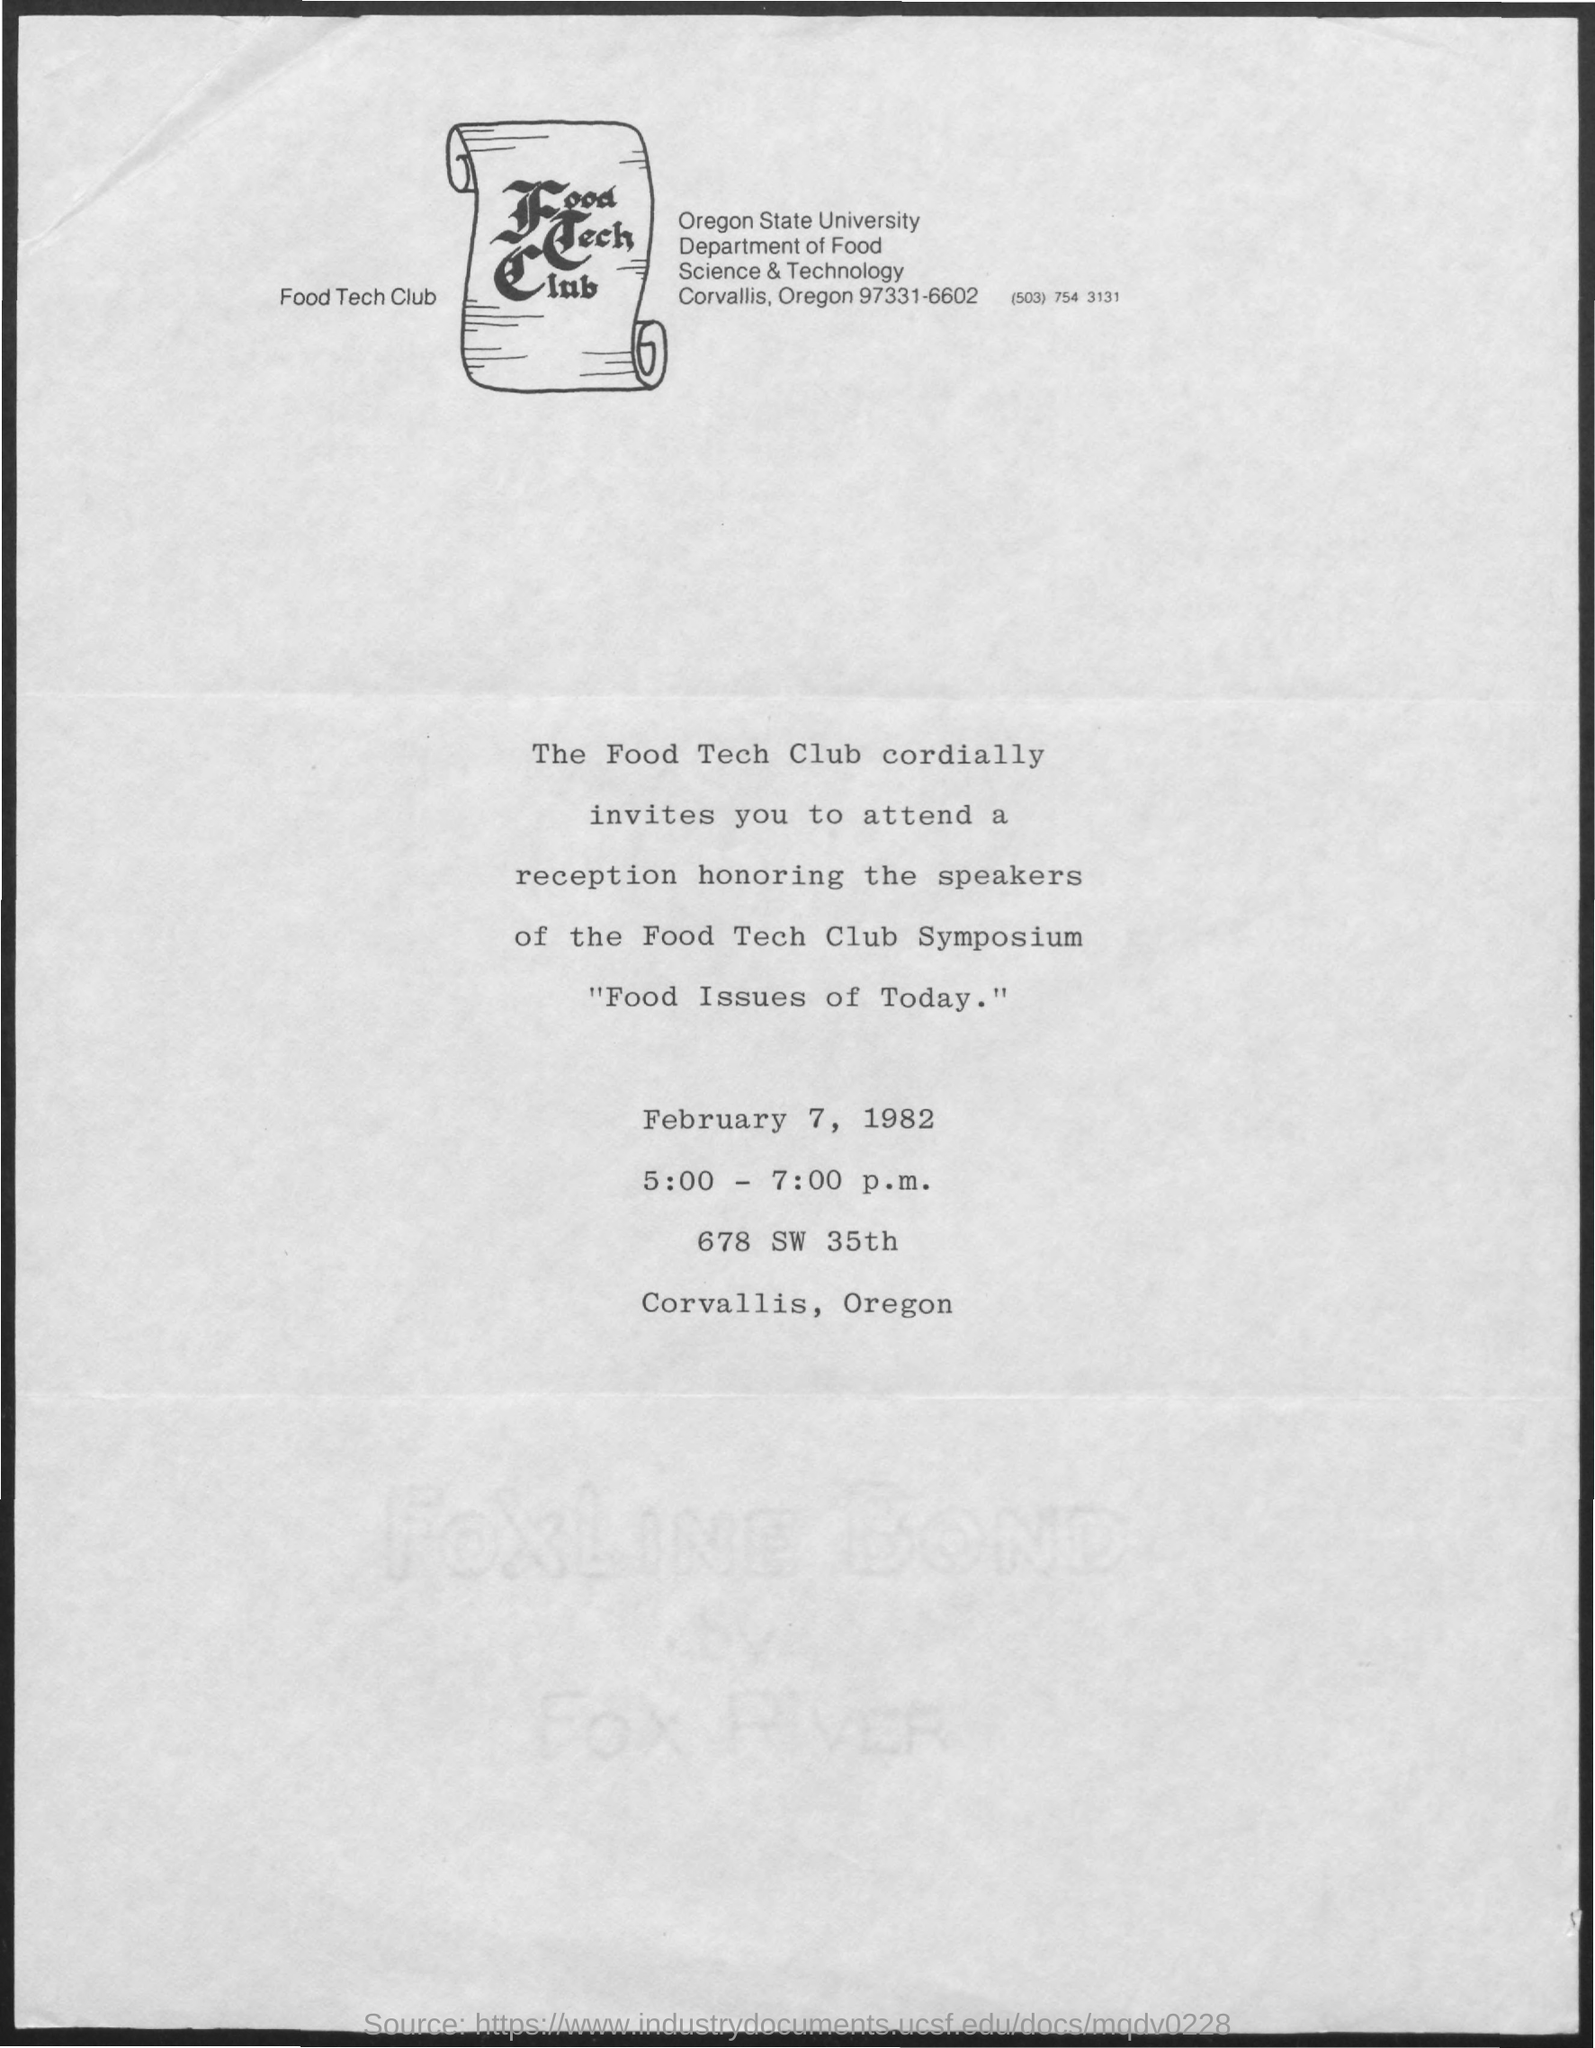When is the symposium?
Give a very brief answer. February 7, 1982. 